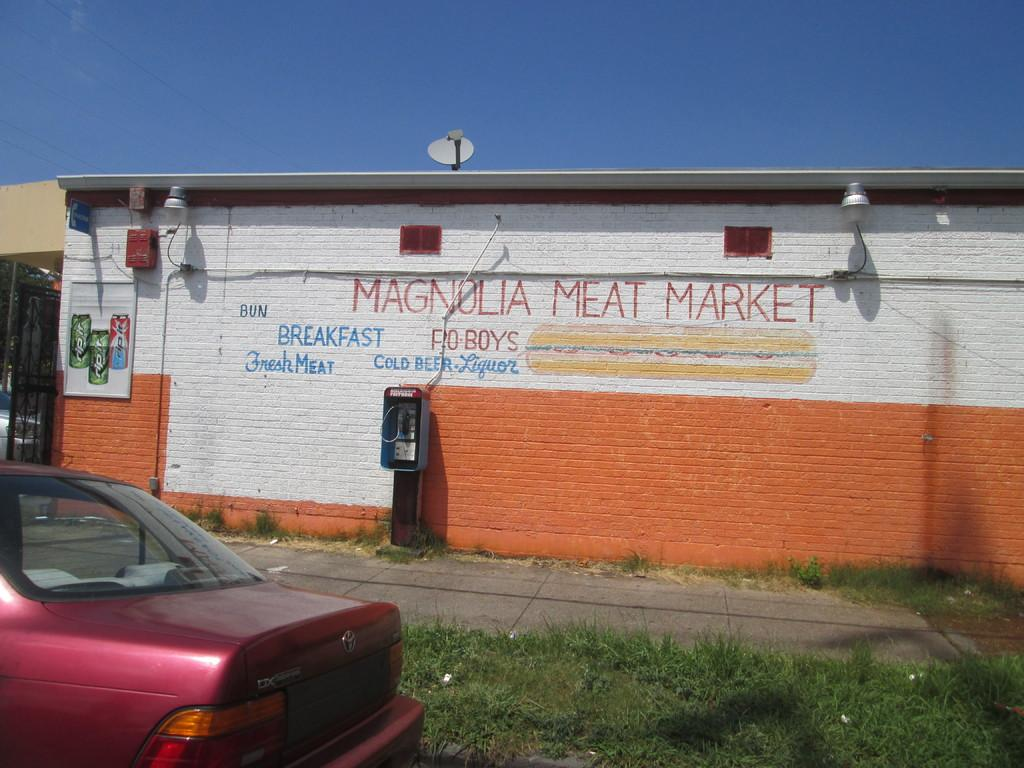What is located on the ground in the image? There is a car on the ground in the image. What type of vegetation can be seen in the image? There is grass visible in the image. What is on the wall in the image? There is a painting on the wall in the image. What can be seen in the background of the image? The sky is visible in the background of the image. Where is the tent located in the image? There is no tent present in the image. Can you describe the house in the image? There is no house present in the image. 